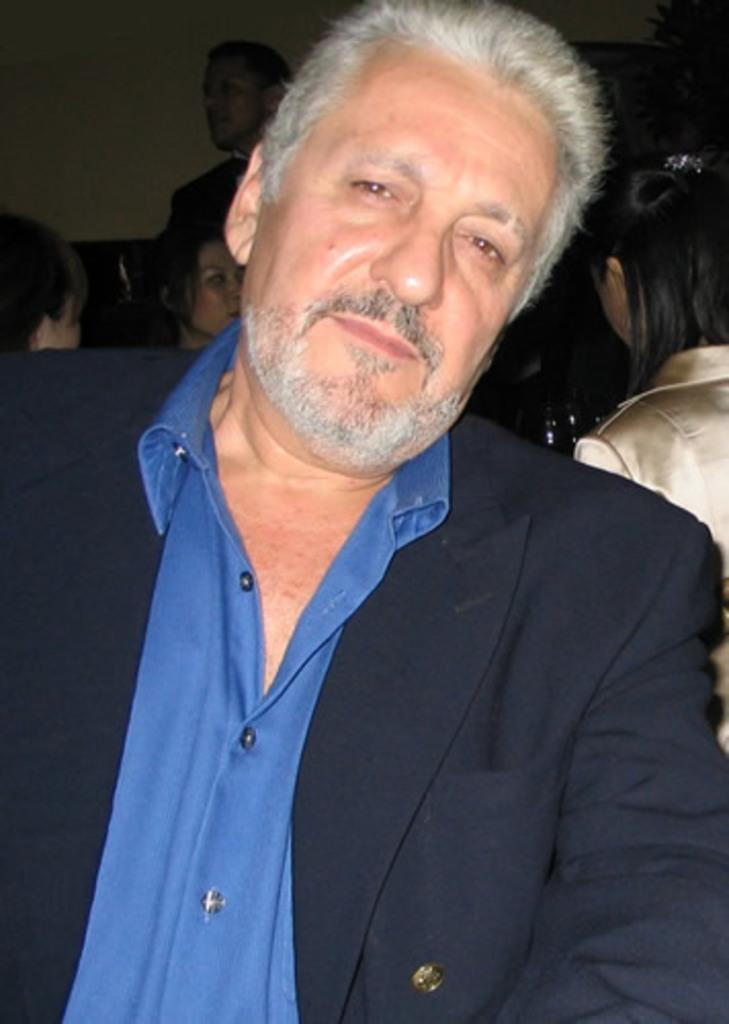Who is the main subject in the image? There is a man in the image. What is the man wearing in the image? The man is wearing a coat and a blue shirt. Can you describe the background of the image? There are many people in the background of the image. How many frogs can be seen jumping on the man's elbow in the image? There are no frogs present in the image, and the man's elbow is not visible. 